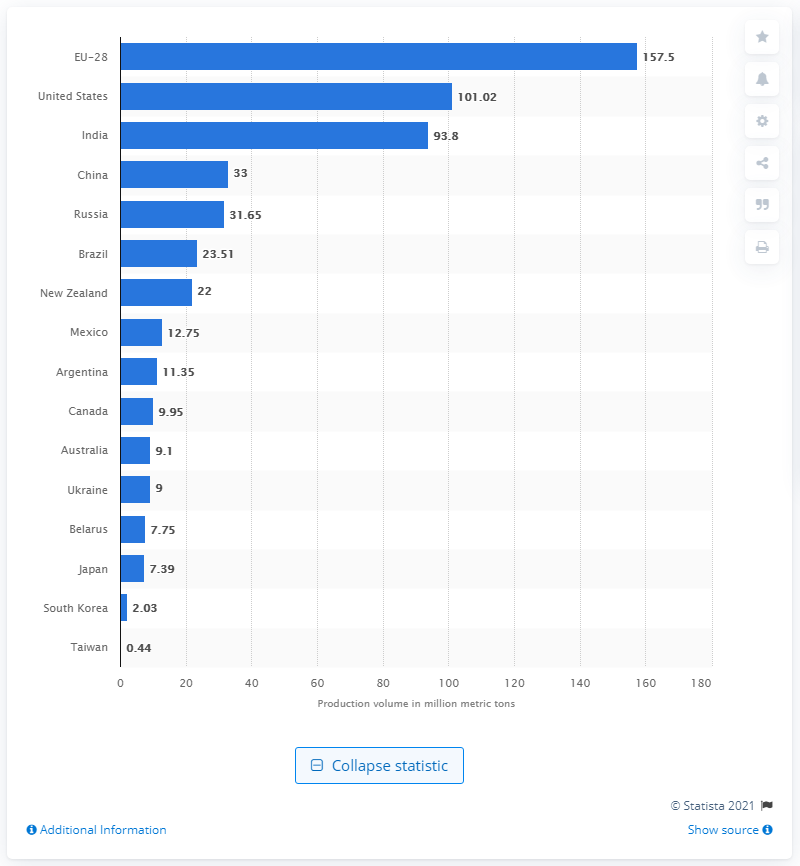Specify some key components in this picture. In 2020, the 28 member states of the European Union produced a total of 157.5 million metric tons of cow milk. In 2020, the production volume of cow milk in the United States was 101.02 million gallons. 